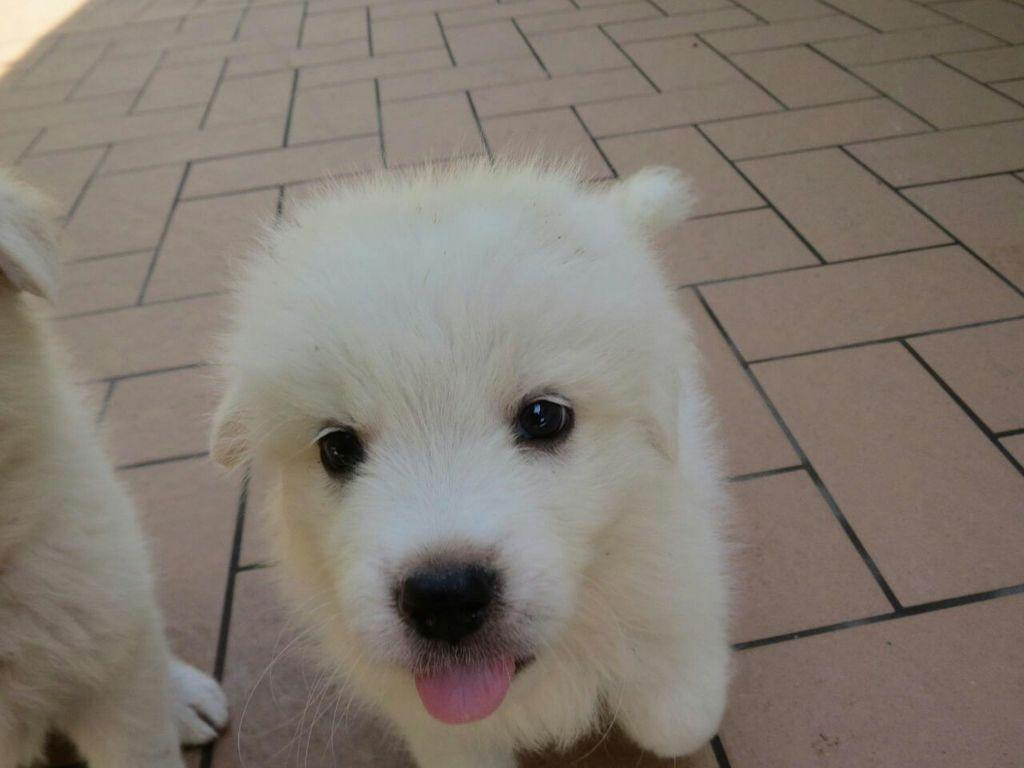How many dogs are present in the image? There are two dogs in the image. What is the position of the dogs in the image? The dogs are standing on the floor. What type of airplane is the owner flying in the image? There is no airplane or owner present in the image; it features two dogs standing on the floor. 